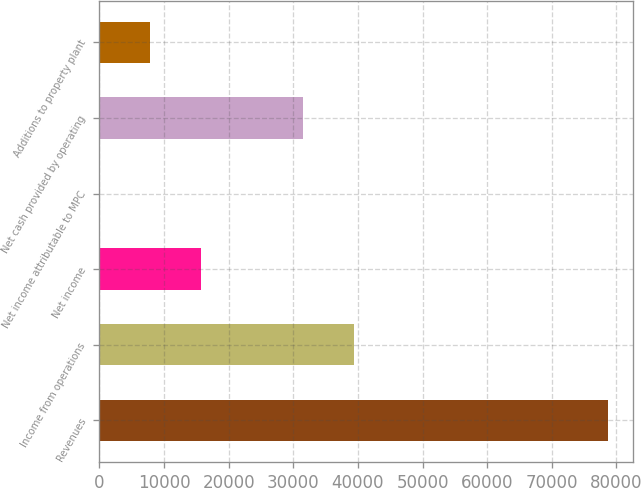Convert chart. <chart><loc_0><loc_0><loc_500><loc_500><bar_chart><fcel>Revenues<fcel>Income from operations<fcel>Net income<fcel>Net income attributable to MPC<fcel>Net cash provided by operating<fcel>Additions to property plant<nl><fcel>78638<fcel>39322.3<fcel>15733<fcel>6.7<fcel>31459.2<fcel>7869.83<nl></chart> 